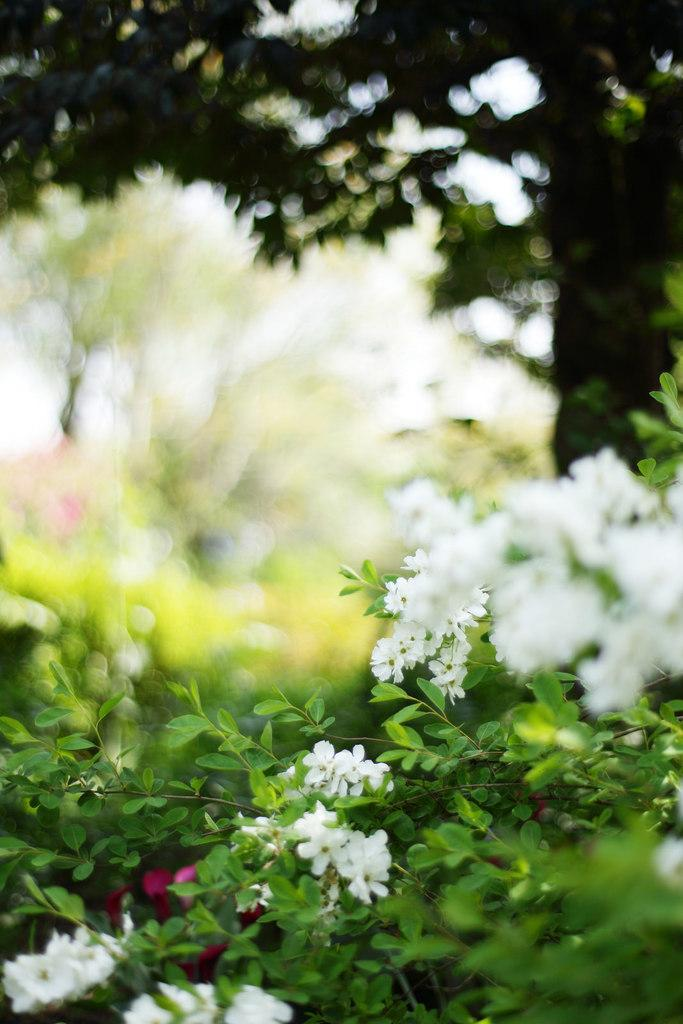What type of vegetation is present in the image? There are many trees and plants in the image. What can be observed about the plants in the image? The plants have flowers. How would you describe the background of the image? The background of the image is blurred. What type of stew is being prepared in the image? There is no stew present in the image; it features trees, plants, and flowers. How many kittens can be seen playing among the plants in the image? There are no kittens present in the image; it only features trees, plants, and flowers. 